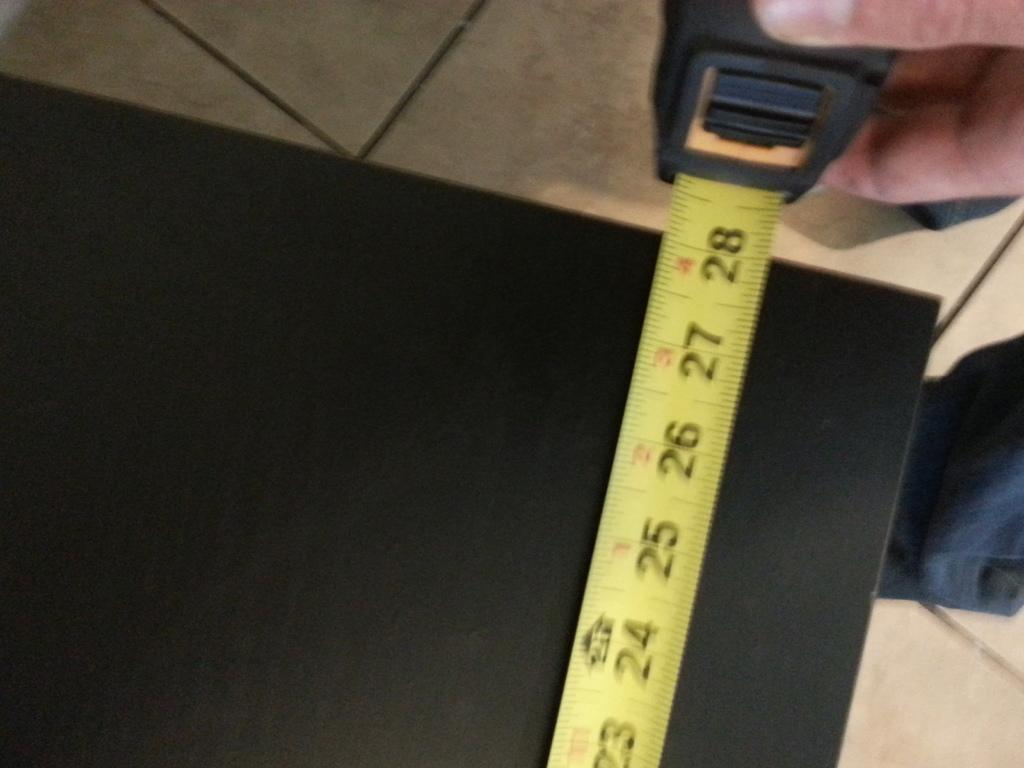<image>
Describe the image concisely. The tape measure shows the black table to be 28 inches in length. 